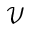<formula> <loc_0><loc_0><loc_500><loc_500>\mathcal { V }</formula> 